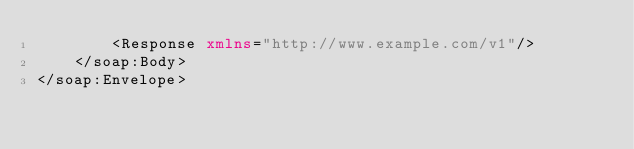Convert code to text. <code><loc_0><loc_0><loc_500><loc_500><_XML_>		<Response xmlns="http://www.example.com/v1"/>
	</soap:Body>
</soap:Envelope></code> 